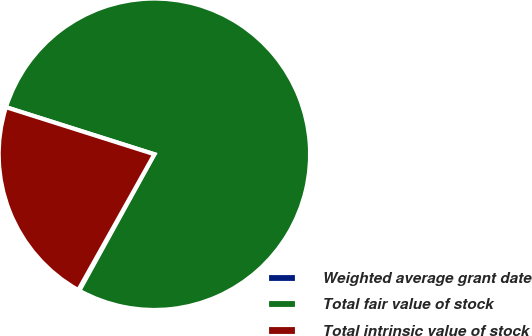Convert chart. <chart><loc_0><loc_0><loc_500><loc_500><pie_chart><fcel>Weighted average grant date<fcel>Total fair value of stock<fcel>Total intrinsic value of stock<nl><fcel>0.12%<fcel>78.11%<fcel>21.76%<nl></chart> 